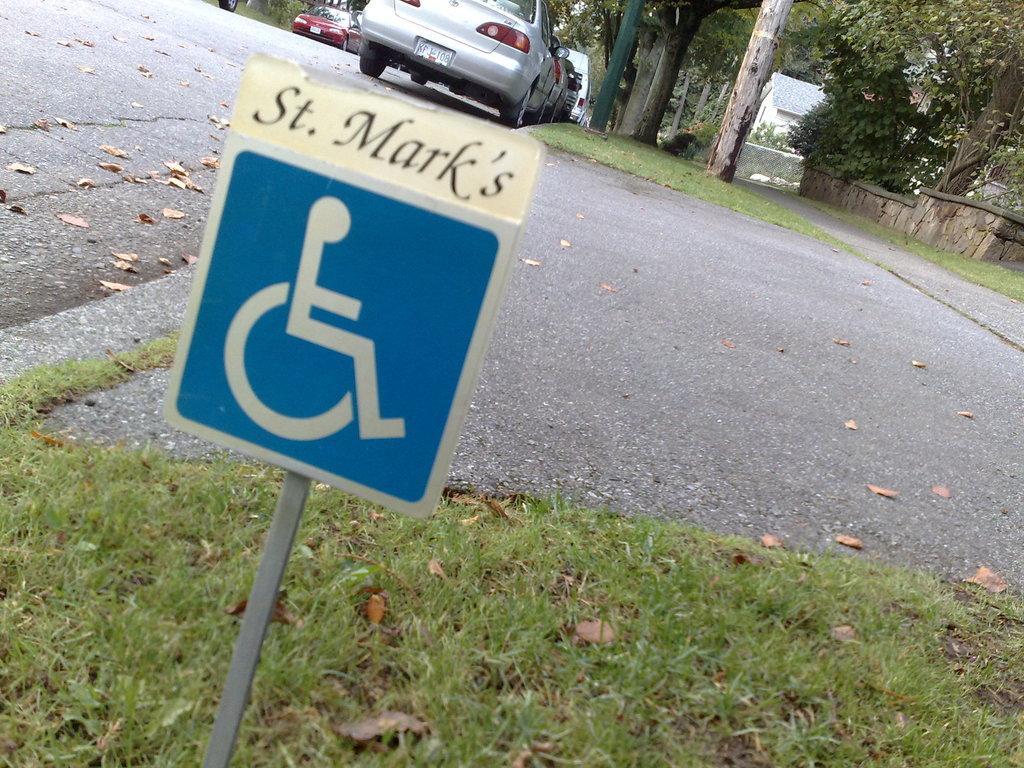Describe this image in one or two sentences. In this picture, we can see the road, ground covered with grass, and we can see some objects on the ground, we can see trees, plants, wall, houses, vehicles, signboard and pole. 